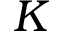<formula> <loc_0><loc_0><loc_500><loc_500>K</formula> 